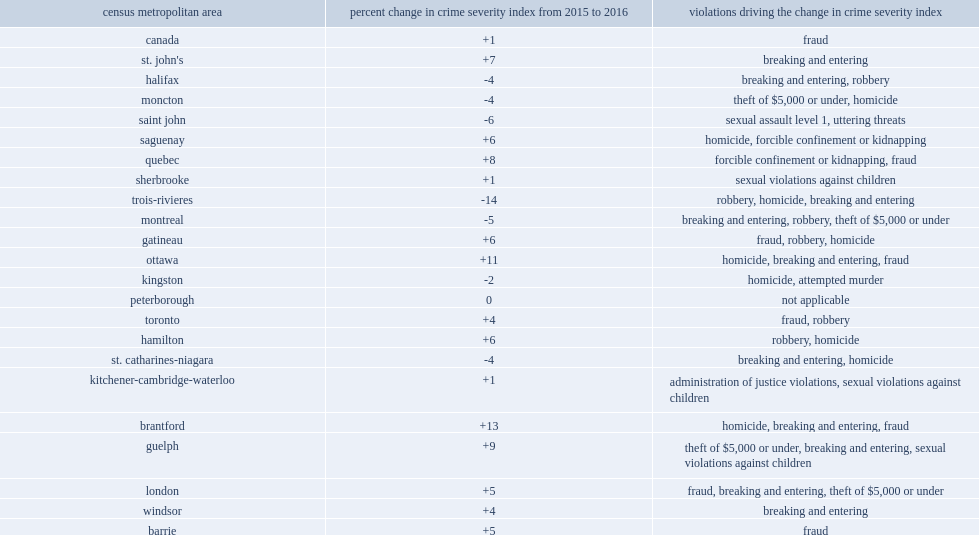Between 2015 and 2016, how many percentage point has trois-rivieres reported decline in csi? 14. Which reported the lowest crime rate amongst cmas in 2016? Trois-rivieres. 